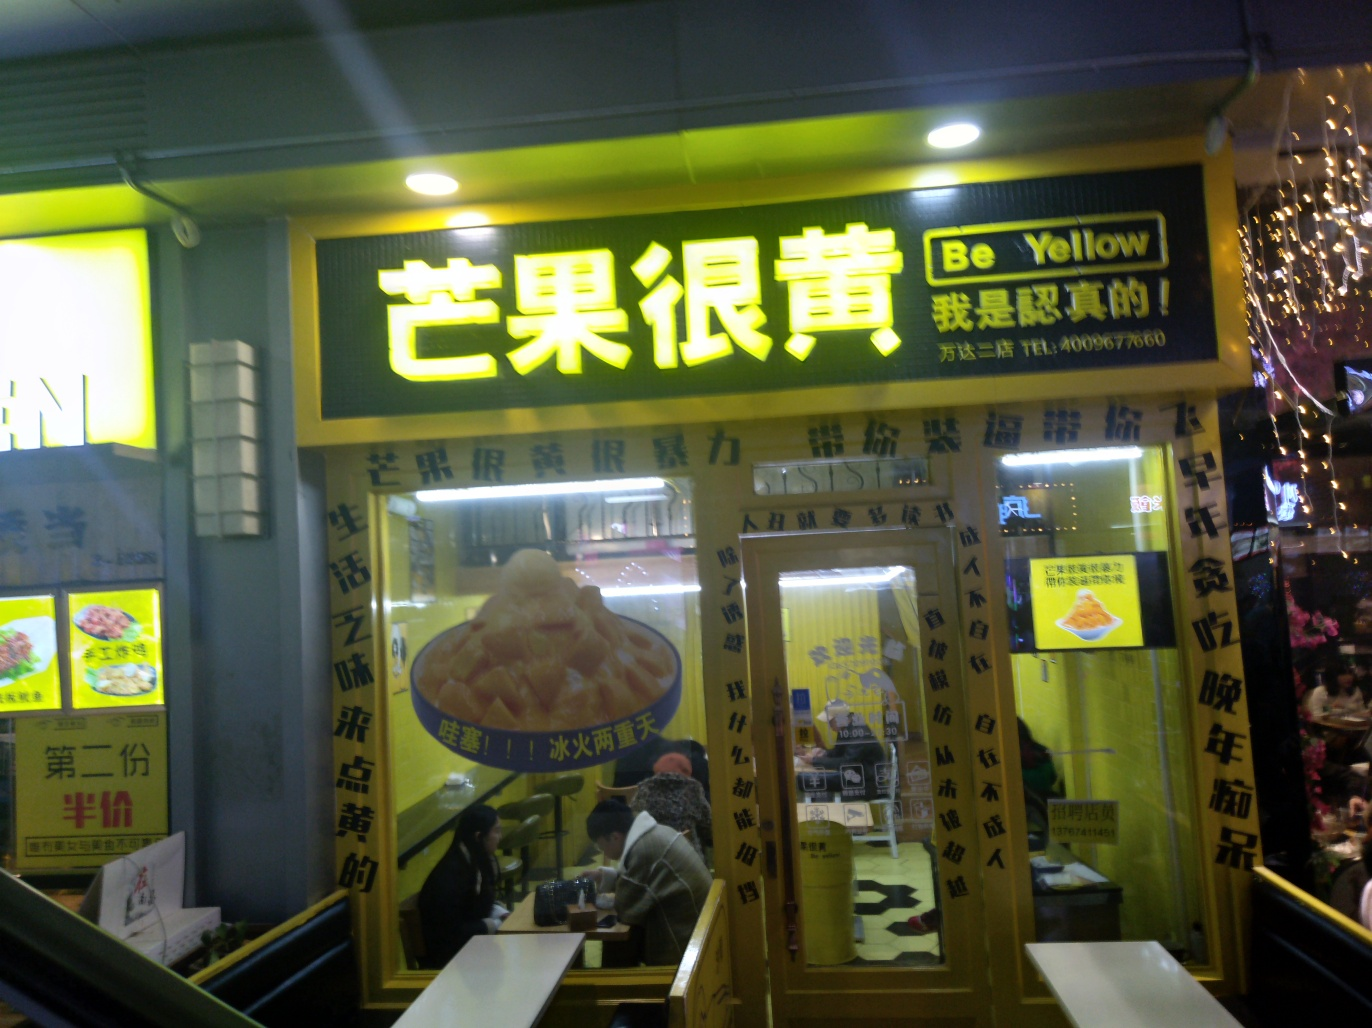Could you infer the potential popularity of this place? Although it's difficult to make a definitive assessment from a single image, several cues suggest that this restaurant might enjoy a certain level of popularity. The presence of customers dining inside implies it is frequented by patrons. Also, the bold and bright signage is designed to attract attention, which could indicate an established presence and confidence in attracting customers. 